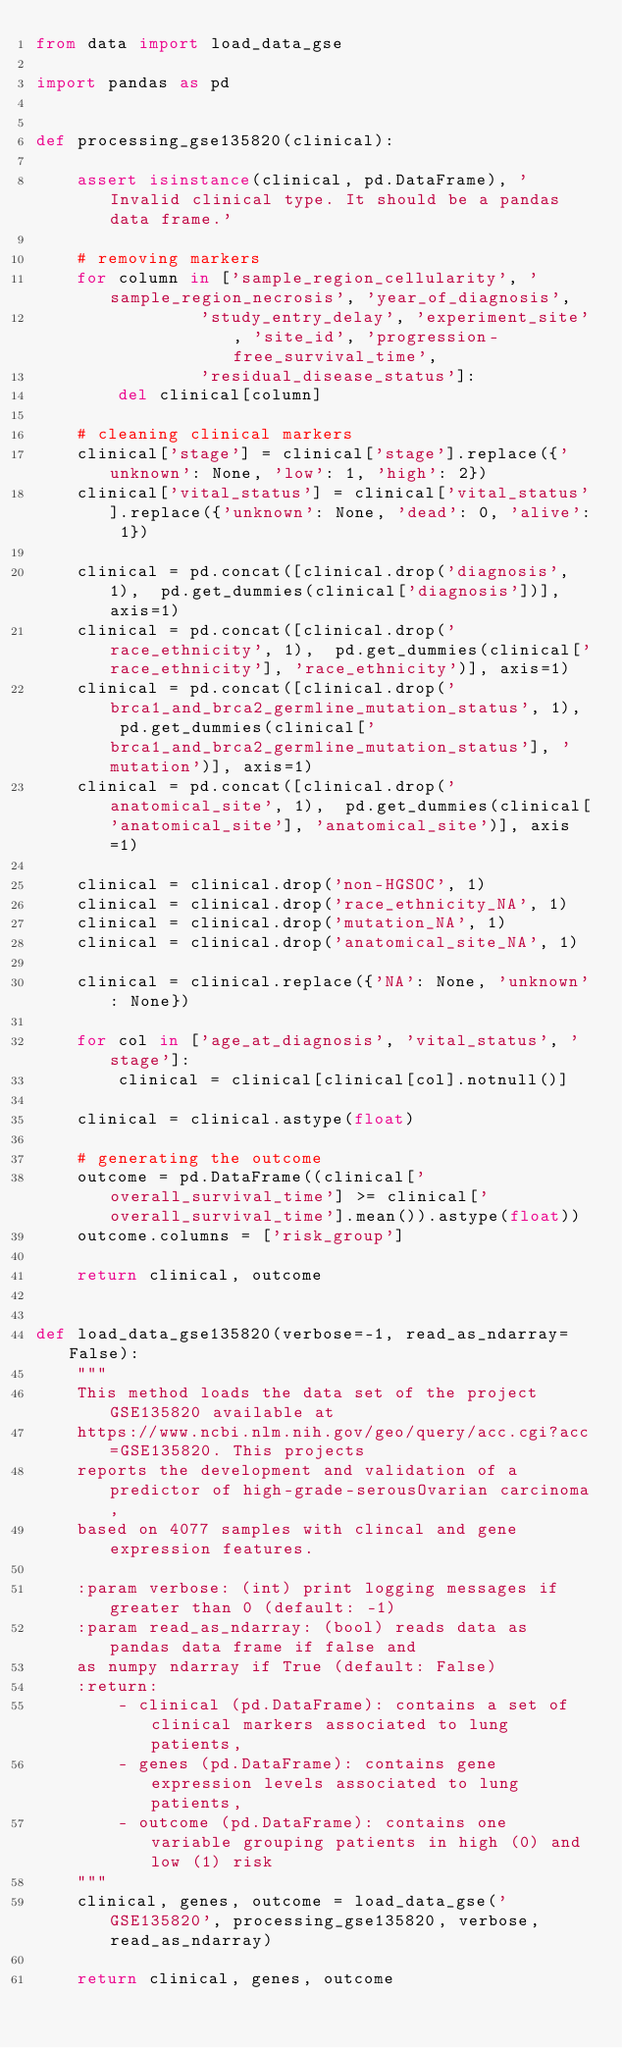<code> <loc_0><loc_0><loc_500><loc_500><_Python_>from data import load_data_gse

import pandas as pd


def processing_gse135820(clinical):

    assert isinstance(clinical, pd.DataFrame), 'Invalid clinical type. It should be a pandas data frame.'

    # removing markers
    for column in ['sample_region_cellularity', 'sample_region_necrosis', 'year_of_diagnosis',
                'study_entry_delay', 'experiment_site', 'site_id', 'progression-free_survival_time',
                'residual_disease_status']:
        del clinical[column]
    
    # cleaning clinical markers
    clinical['stage'] = clinical['stage'].replace({'unknown': None, 'low': 1, 'high': 2})
    clinical['vital_status'] = clinical['vital_status'].replace({'unknown': None, 'dead': 0, 'alive': 1})

    clinical = pd.concat([clinical.drop('diagnosis', 1),  pd.get_dummies(clinical['diagnosis'])], axis=1)
    clinical = pd.concat([clinical.drop('race_ethnicity', 1),  pd.get_dummies(clinical['race_ethnicity'], 'race_ethnicity')], axis=1)
    clinical = pd.concat([clinical.drop('brca1_and_brca2_germline_mutation_status', 1),  pd.get_dummies(clinical['brca1_and_brca2_germline_mutation_status'], 'mutation')], axis=1)
    clinical = pd.concat([clinical.drop('anatomical_site', 1),  pd.get_dummies(clinical['anatomical_site'], 'anatomical_site')], axis=1)

    clinical = clinical.drop('non-HGSOC', 1)
    clinical = clinical.drop('race_ethnicity_NA', 1)
    clinical = clinical.drop('mutation_NA', 1)
    clinical = clinical.drop('anatomical_site_NA', 1)

    clinical = clinical.replace({'NA': None, 'unknown': None})

    for col in ['age_at_diagnosis', 'vital_status', 'stage']:
        clinical = clinical[clinical[col].notnull()]

    clinical = clinical.astype(float)

    # generating the outcome
    outcome = pd.DataFrame((clinical['overall_survival_time'] >= clinical['overall_survival_time'].mean()).astype(float))
    outcome.columns = ['risk_group']

    return clinical, outcome


def load_data_gse135820(verbose=-1, read_as_ndarray=False):
    """
    This method loads the data set of the project GSE135820 available at
    https://www.ncbi.nlm.nih.gov/geo/query/acc.cgi?acc=GSE135820. This projects
    reports the development and validation of a predictor of high-grade-serousOvarian carcinoma,
    based on 4077 samples with clincal and gene expression features.

    :param verbose: (int) print logging messages if greater than 0 (default: -1)
    :param read_as_ndarray: (bool) reads data as pandas data frame if false and
    as numpy ndarray if True (default: False)
    :return:
        - clinical (pd.DataFrame): contains a set of clinical markers associated to lung patients,
        - genes (pd.DataFrame): contains gene expression levels associated to lung patients,
        - outcome (pd.DataFrame): contains one variable grouping patients in high (0) and low (1) risk
    """
    clinical, genes, outcome = load_data_gse('GSE135820', processing_gse135820, verbose, read_as_ndarray)

    return clinical, genes, outcome</code> 